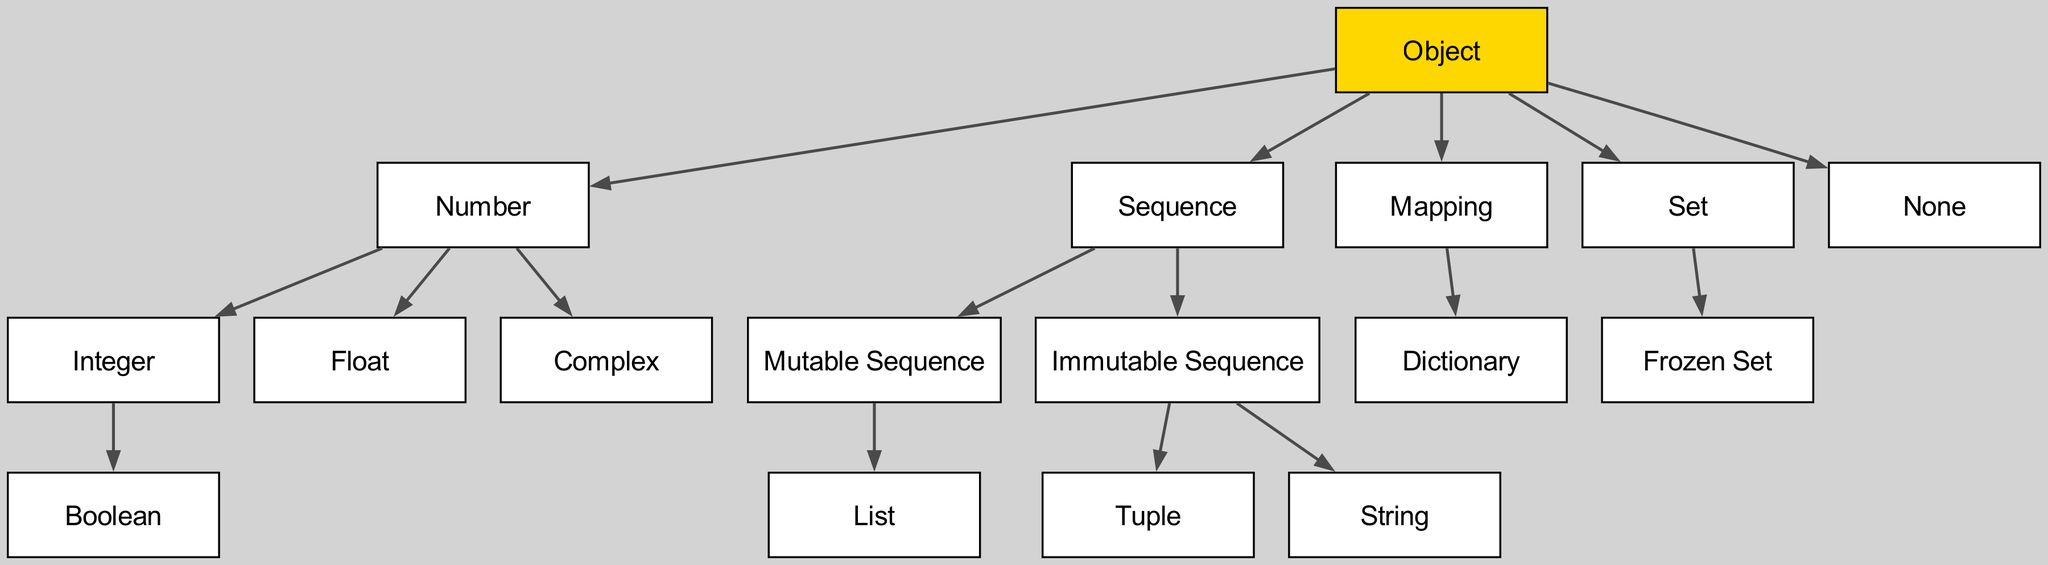What is the root node of the hierarchy? The root node is listed at the top of the diagram, which connects to all other nodes. According to the provided data, the root node is "Object".
Answer: Object How many direct children does the "Number" node have? The "Number" node has three children directly under it: "Integer", "Float", and "Complex". Therefore, by counting them, we find that it has 3 direct children.
Answer: 3 What are the types of sequences shown in the diagram? The "Sequence" node has two direct children listed in the diagram: "Mutable Sequence" and "Immutable Sequence". These are the two types of sequences represented.
Answer: Mutable Sequence, Immutable Sequence Which type under "Mapping" is present in the hierarchy? The "Mapping" node directly connects to one child node listed in the structure: "Dictionary". This makes "Dictionary" the only type displayed under "Mapping".
Answer: Dictionary Which node is a child of the "Integer" node? The child node directly under "Integer" is "Boolean", based on the hierarchy. By tracing the relationship from the "Integer" to its child, we find that it is "Boolean".
Answer: Boolean How many total types are categorized under "Sequence"? The "Sequence" node contains two categories: "Mutable Sequence" and "Immutable Sequence". Looking further, "Mutable Sequence" has one child, "List", and "Immutable Sequence" has two children, "Tuple" and "String". Adding these gives a total of 4 types (1 from Mutable and 2 from Immutable).
Answer: 4 What is the relationship between "Set" and "Frozen Set"? "Set" is a parent node that has a child node called "Frozen Set". This indicates that "Frozen Set" is a specific type of "Set". Therefore, their relationship is hierarchical, where "Set" is the parent of "Frozen Set".
Answer: Parent-Child How many types fall under the "Number" category? The "Number" node has three direct children ("Integer", "Float", "Complex") as well as one indirect child through "Integer" ("Boolean"). So by counting all of these, there are four types under "Number".
Answer: 4 Is "None" a child node of any other node in this hierarchy? "None" appears as a direct child of the "Object" node but does not have any children itself. Thus, while it is part of the hierarchy, it does not serve as a parent to any further nodes.
Answer: No 